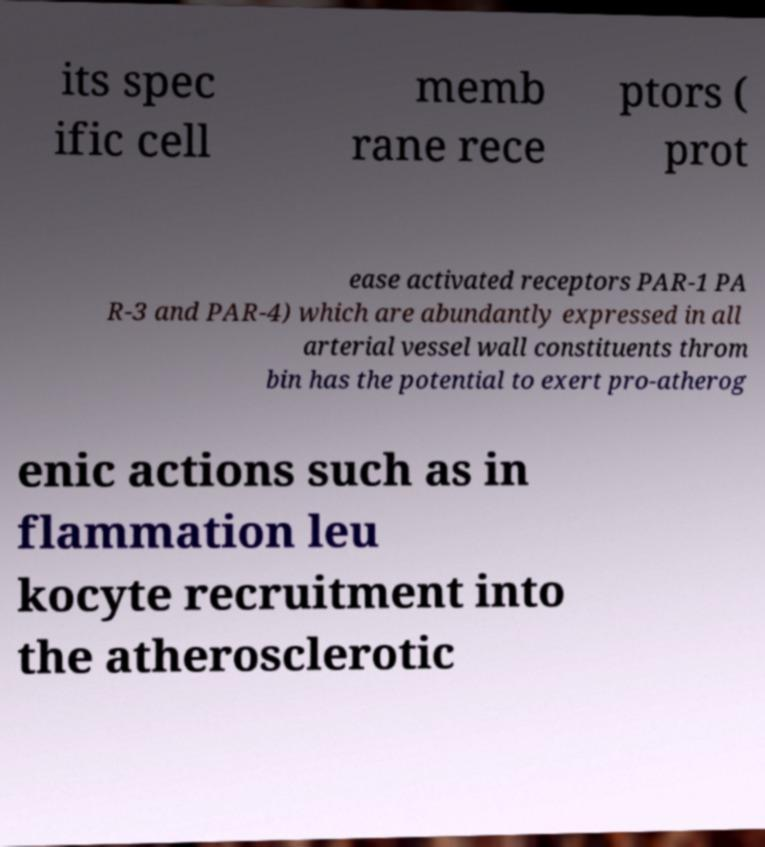Could you assist in decoding the text presented in this image and type it out clearly? its spec ific cell memb rane rece ptors ( prot ease activated receptors PAR-1 PA R-3 and PAR-4) which are abundantly expressed in all arterial vessel wall constituents throm bin has the potential to exert pro-atherog enic actions such as in flammation leu kocyte recruitment into the atherosclerotic 